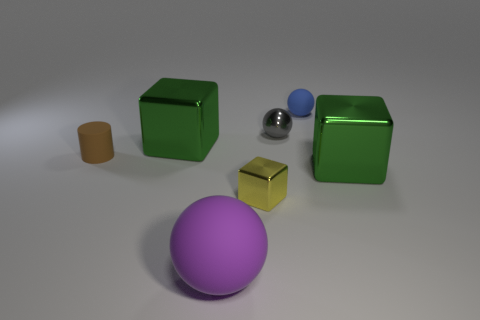Add 1 big purple matte things. How many objects exist? 8 Subtract all tiny metallic cubes. How many cubes are left? 2 Subtract all blue spheres. How many spheres are left? 2 Subtract all blocks. How many objects are left? 4 Subtract all red spheres. Subtract all cyan cylinders. How many spheres are left? 3 Subtract all green blocks. How many cyan cylinders are left? 0 Subtract all big purple matte balls. Subtract all yellow things. How many objects are left? 5 Add 4 tiny shiny blocks. How many tiny shiny blocks are left? 5 Add 2 purple spheres. How many purple spheres exist? 3 Subtract 1 blue balls. How many objects are left? 6 